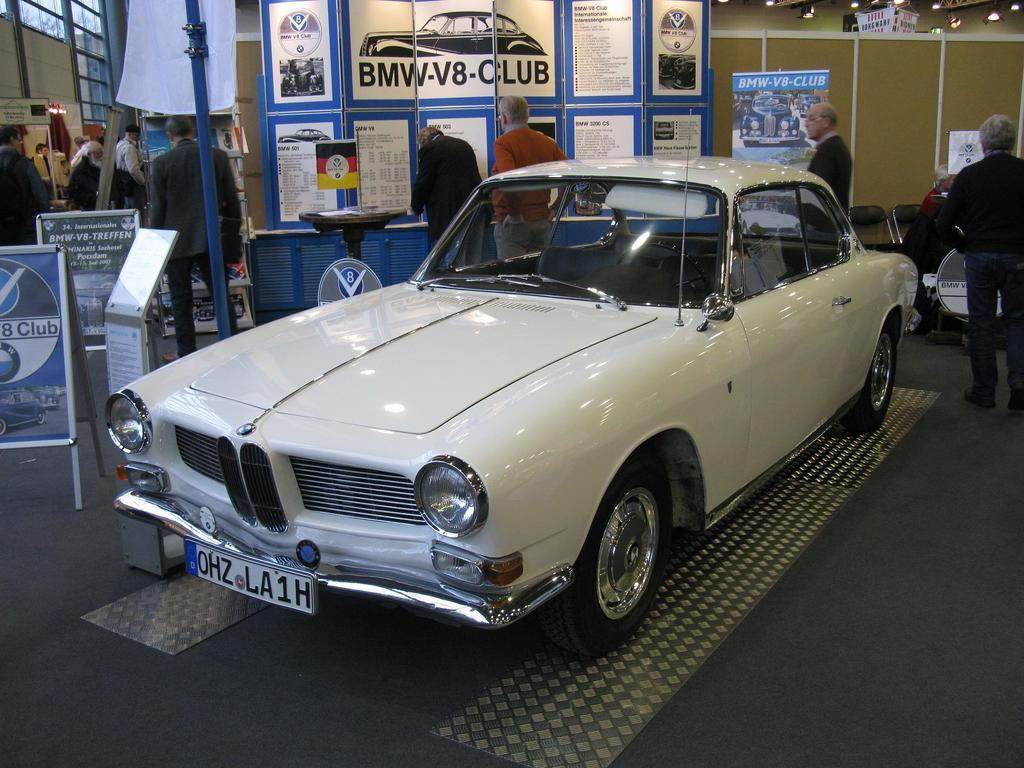What type of vehicle is in the image? There is a white car in the image. What can be seen in the background of the image? There are many people, boards, and banners in the background of the image. What type of silk material is draped over the car in the image? There is no silk material present in the image; it only features a white car and elements in the background. 